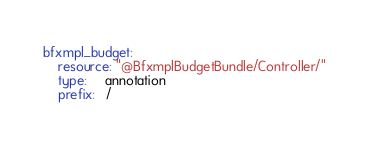Convert code to text. <code><loc_0><loc_0><loc_500><loc_500><_YAML_>bfxmpl_budget:
    resource: "@BfxmplBudgetBundle/Controller/"
    type:     annotation
    prefix:   /

</code> 